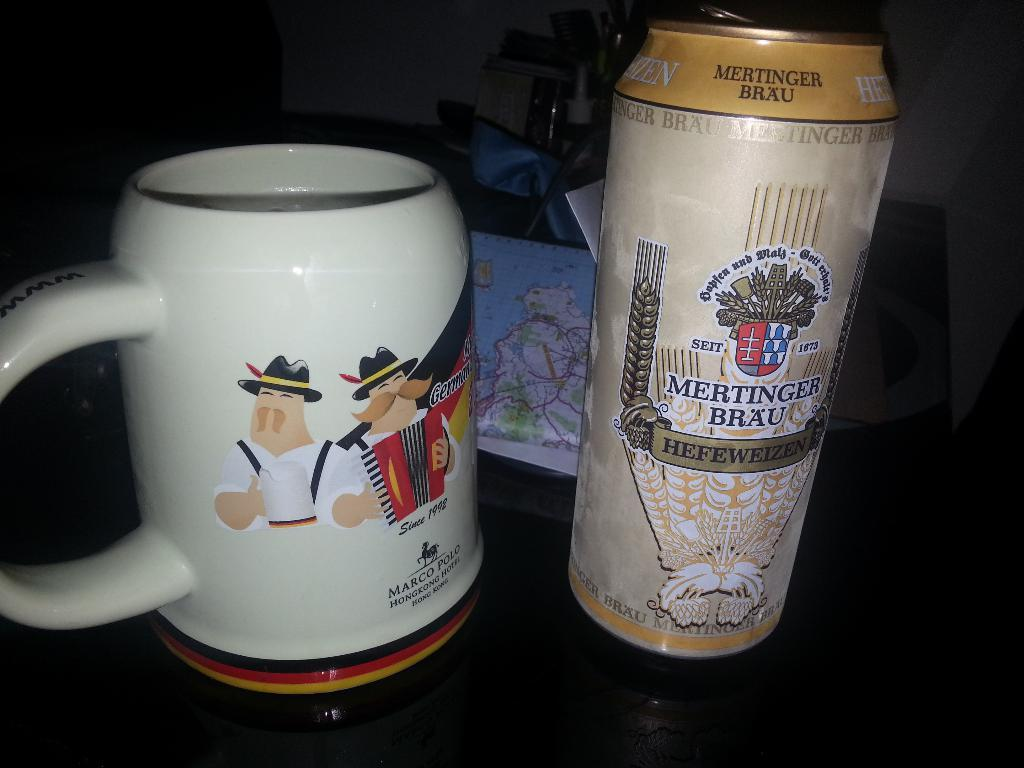<image>
Create a compact narrative representing the image presented. A can of Mertinger Brau sits next to a mug with cartoons of German men. 